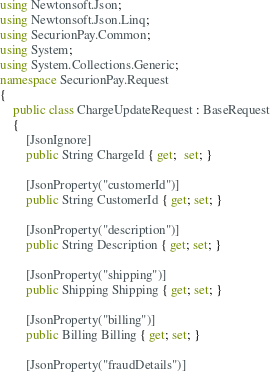<code> <loc_0><loc_0><loc_500><loc_500><_C#_>using Newtonsoft.Json;
using Newtonsoft.Json.Linq;
using SecurionPay.Common;
using System;
using System.Collections.Generic;
namespace SecurionPay.Request
{
    public class ChargeUpdateRequest : BaseRequest
    {
        [JsonIgnore]
        public String ChargeId { get;  set; }

        [JsonProperty("customerId")]
        public String CustomerId { get; set; }

        [JsonProperty("description")]
        public String Description { get; set; }

        [JsonProperty("shipping")]
        public Shipping Shipping { get; set; }

        [JsonProperty("billing")]
        public Billing Billing { get; set; }

        [JsonProperty("fraudDetails")]</code> 